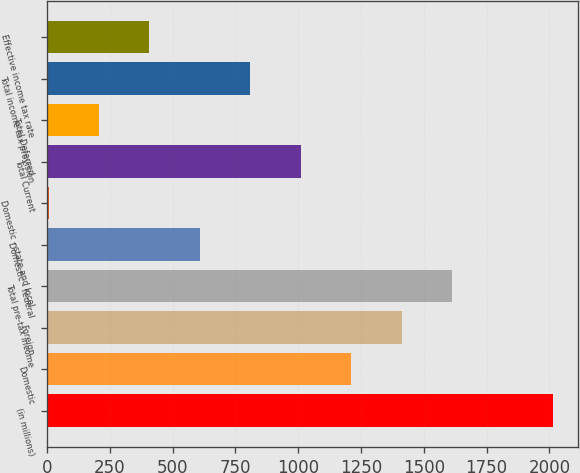Convert chart to OTSL. <chart><loc_0><loc_0><loc_500><loc_500><bar_chart><fcel>(in millions)<fcel>Domestic<fcel>Foreign<fcel>Total pre-tax income<fcel>Domestic - federal<fcel>Domestic - state and local<fcel>Total Current<fcel>Total Deferred<fcel>Total income tax provision<fcel>Effective income tax rate<nl><fcel>2015<fcel>1211.4<fcel>1412.3<fcel>1613.2<fcel>608.7<fcel>6<fcel>1010.5<fcel>206.9<fcel>809.6<fcel>407.8<nl></chart> 